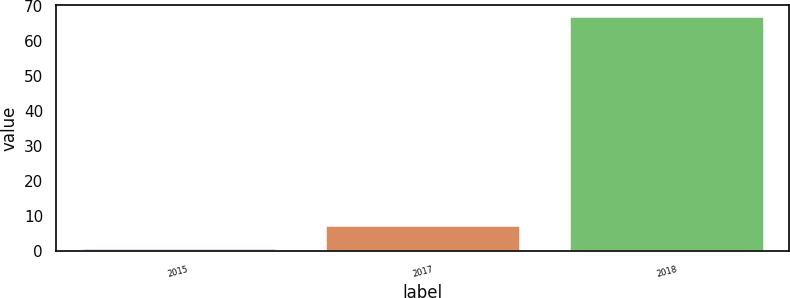Convert chart. <chart><loc_0><loc_0><loc_500><loc_500><bar_chart><fcel>2015<fcel>2017<fcel>2018<nl><fcel>1<fcel>7.6<fcel>67<nl></chart> 